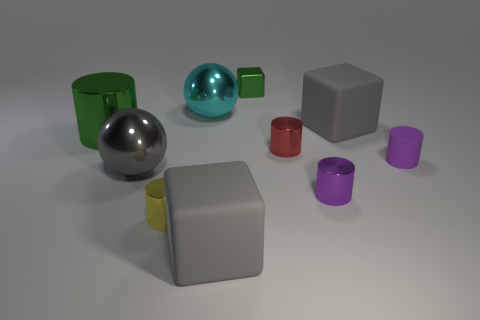Subtract all rubber blocks. How many blocks are left? 1 Subtract 2 cylinders. How many cylinders are left? 3 Subtract all purple blocks. Subtract all blue cylinders. How many blocks are left? 3 Subtract all gray spheres. How many purple cylinders are left? 2 Subtract all brown rubber cubes. Subtract all big metallic balls. How many objects are left? 8 Add 2 cylinders. How many cylinders are left? 7 Add 7 small purple matte cylinders. How many small purple matte cylinders exist? 8 Subtract all green cylinders. How many cylinders are left? 4 Subtract 0 purple blocks. How many objects are left? 10 Subtract all cubes. How many objects are left? 7 